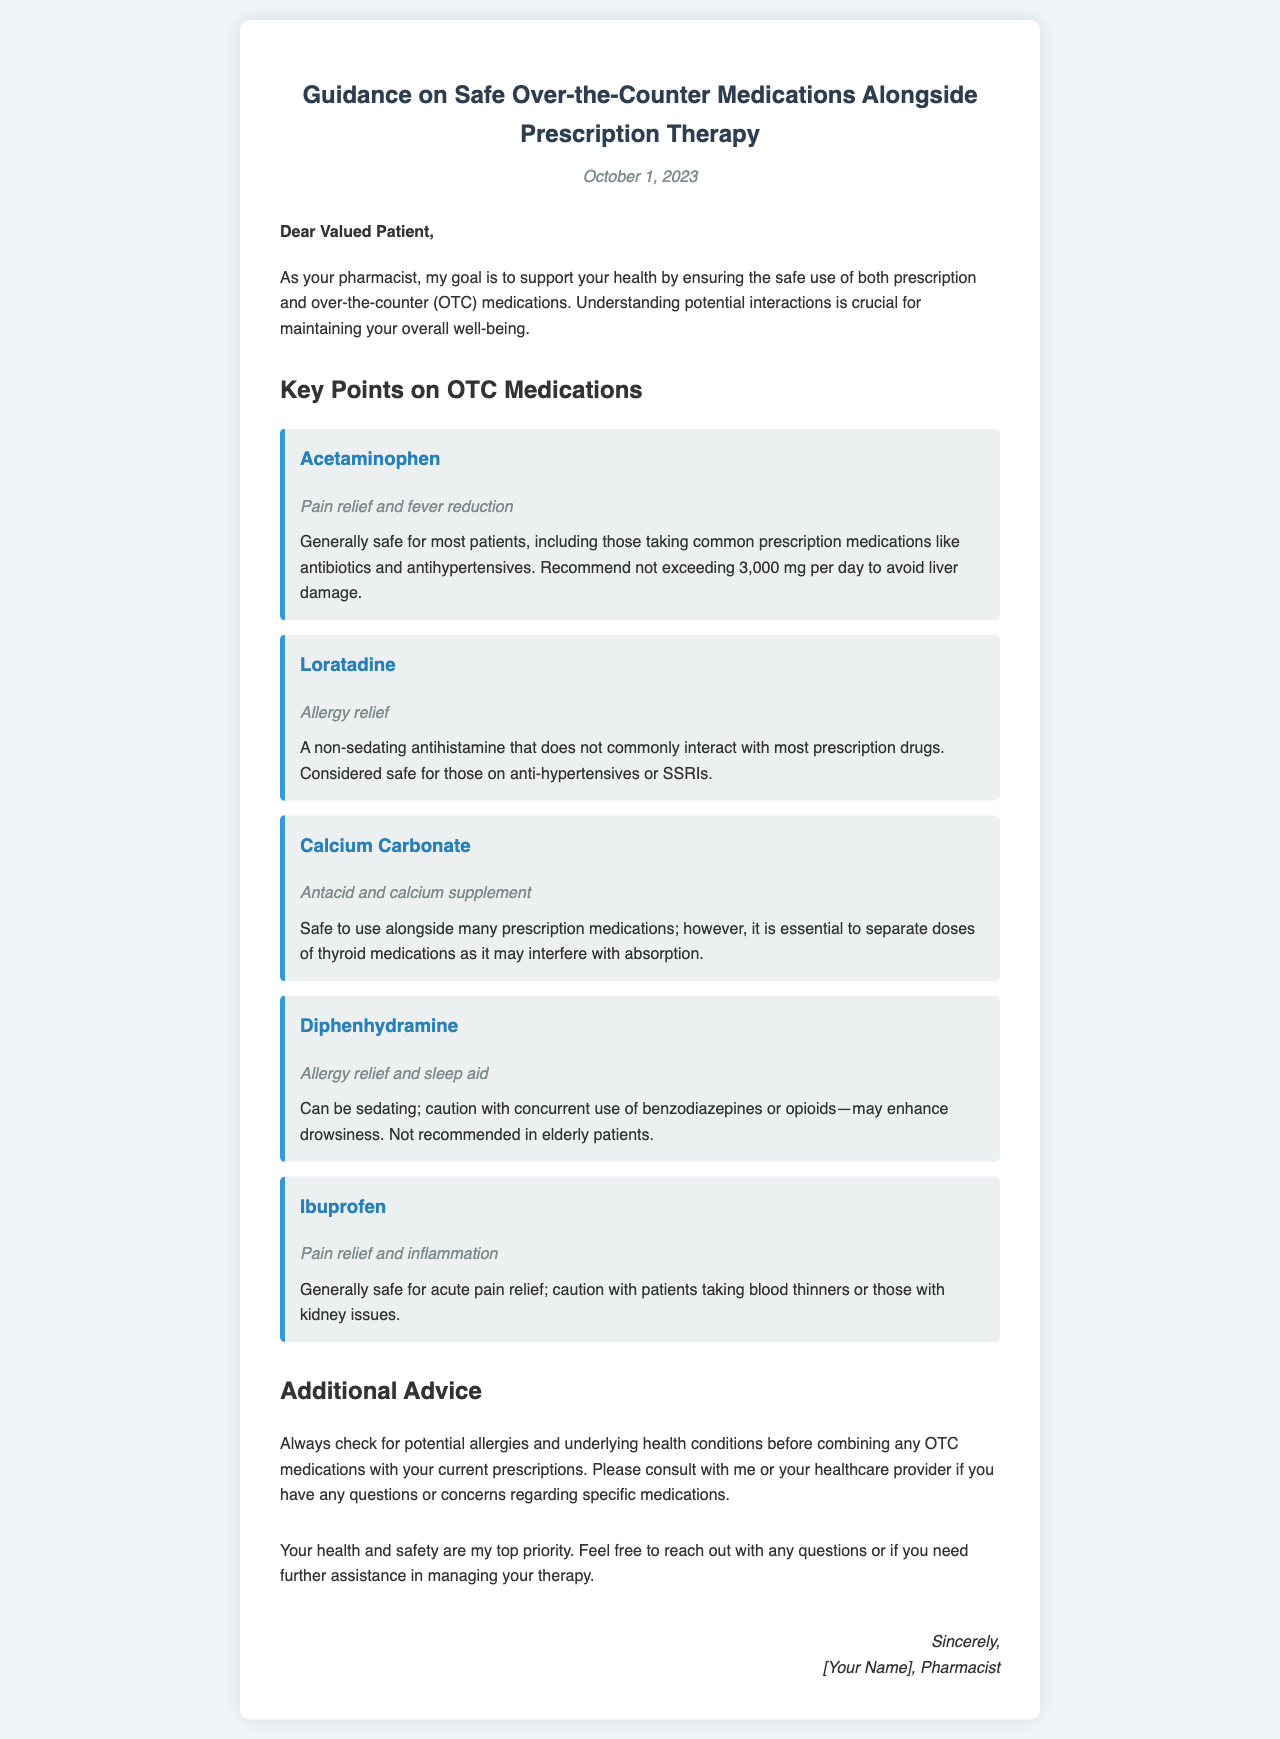What is the date of the letter? The date of the letter is explicitly mentioned at the top of the document.
Answer: October 1, 2023 Who is the recipient of the letter? The recipient is addressed at the beginning of the letter as a valued patient.
Answer: Valued Patient What is the maximum recommended daily dosage of Acetaminophen? This information is provided in the note section of the Acetaminophen medication information.
Answer: 3,000 mg Which OTC medication is mentioned as not commonly interacting with prescription drugs? This information can be found in the note for Loratadine in the document.
Answer: Loratadine What potential issue is highlighted with the use of Calcium Carbonate? The document indicates a specific interaction with thyroid medications.
Answer: Interferes with absorption What is the main purpose of the letter? The letter outlines guidance on safe use of OTC medications alongside prescription therapy.
Answer: Guidance on safe OTC medications Which medication is mentioned as having sedating effects? This is specifically mentioned in the note for Diphenhydramine.
Answer: Diphenhydramine What advice is given regarding allergies and health conditions? The document advises checking for these factors before combining medications.
Answer: Check for potential allergies and underlying health conditions 